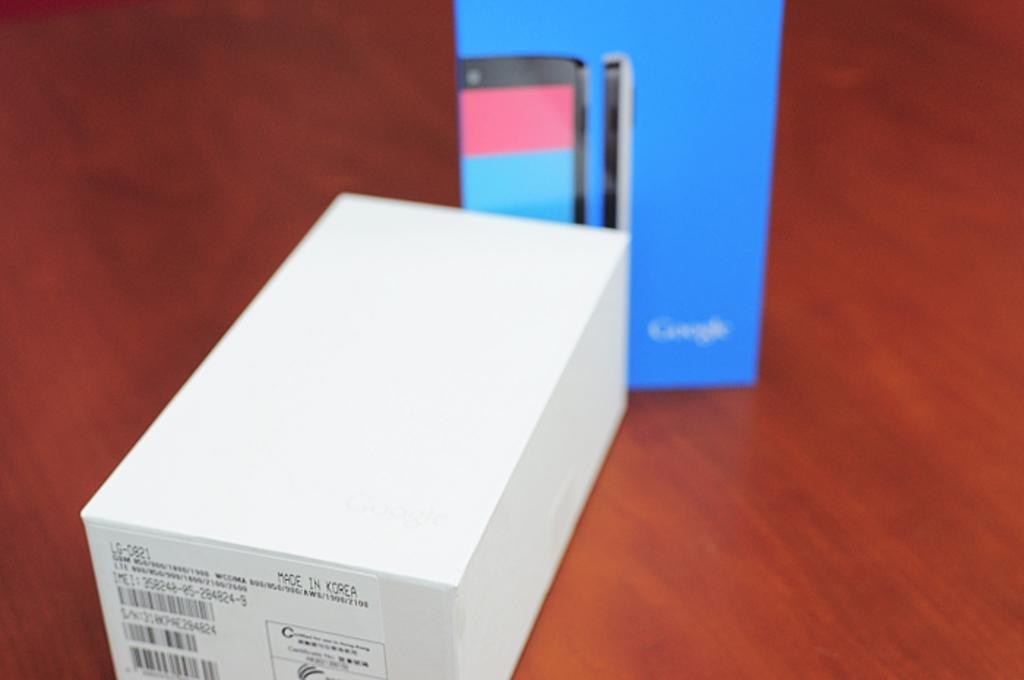In what country was this phone made?
Provide a succinct answer. Korea. 